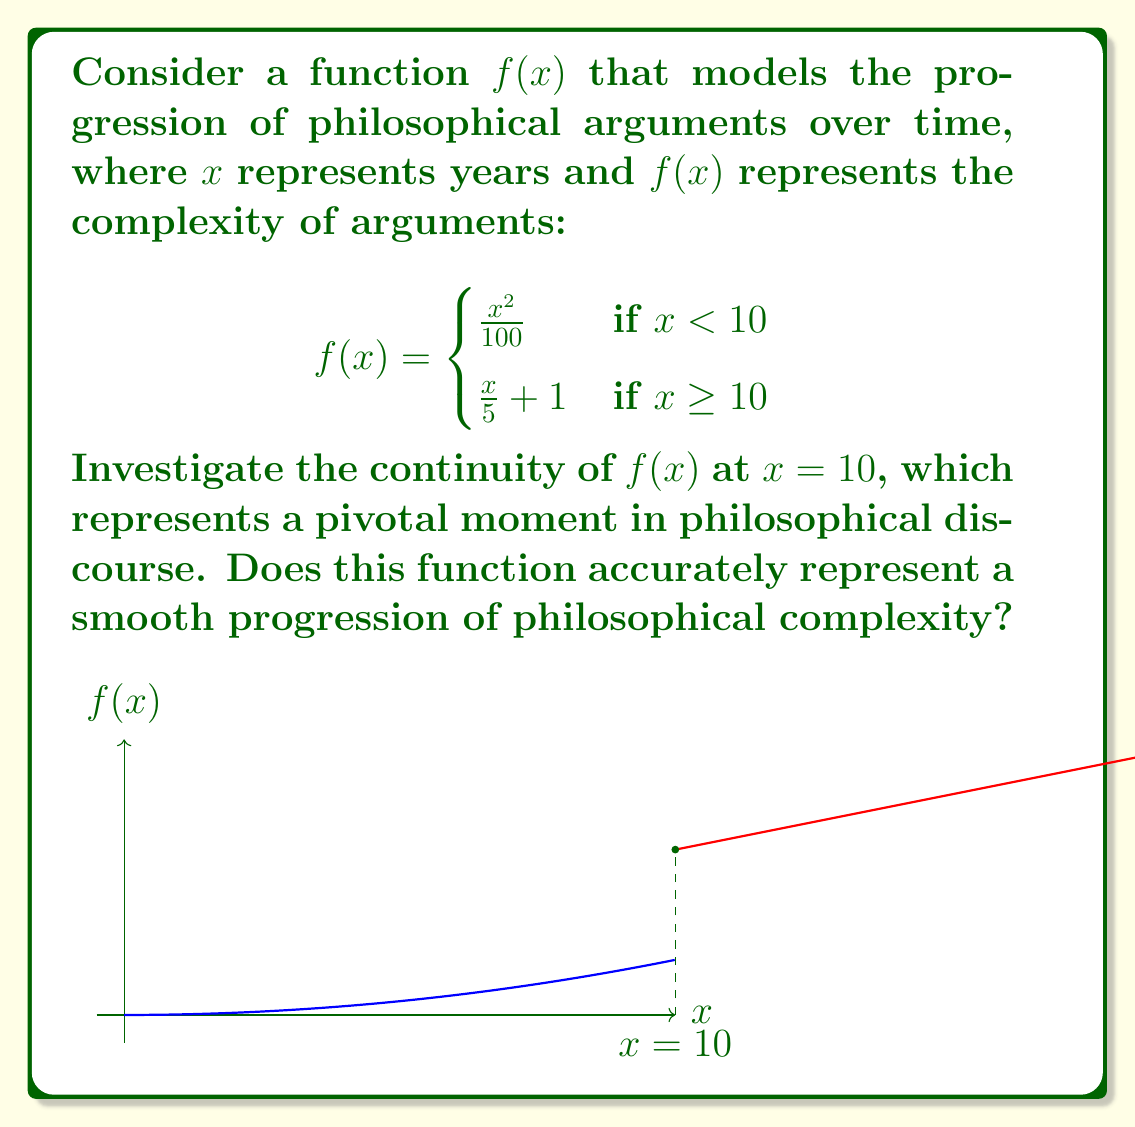Solve this math problem. To investigate the continuity of $f(x)$ at $x = 10$, we need to check three conditions:

1. $f(x)$ is defined at $x = 10$
2. $\lim_{x \to 10^-} f(x)$ exists
3. $\lim_{x \to 10^+} f(x)$ exists
4. $\lim_{x \to 10^-} f(x) = \lim_{x \to 10^+} f(x) = f(10)$

Step 1: Check if $f(x)$ is defined at $x = 10$
$f(10) = \frac{10}{5} + 1 = 3$, so $f(x)$ is defined at $x = 10$.

Step 2: Calculate $\lim_{x \to 10^-} f(x)$
$\lim_{x \to 10^-} f(x) = \lim_{x \to 10^-} \frac{x^2}{100} = \frac{10^2}{100} = 1$

Step 3: Calculate $\lim_{x \to 10^+} f(x)$
$\lim_{x \to 10^+} f(x) = \lim_{x \to 10^+} (\frac{x}{5} + 1) = \frac{10}{5} + 1 = 3$

Step 4: Compare the limits and $f(10)$
$\lim_{x \to 10^-} f(x) = 1$
$\lim_{x \to 10^+} f(x) = 3$
$f(10) = 3$

Since $\lim_{x \to 10^-} f(x) \neq \lim_{x \to 10^+} f(x)$, the function is not continuous at $x = 10$.

This discontinuity suggests that the function does not accurately represent a smooth progression of philosophical complexity. The abrupt jump at $x = 10$ implies a sudden increase in complexity, which might represent a paradigm shift or revolutionary idea in philosophical discourse rather than a gradual evolution of arguments.
Answer: $f(x)$ is discontinuous at $x = 10$ 